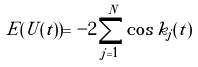Convert formula to latex. <formula><loc_0><loc_0><loc_500><loc_500>E ( U ( t ) ) = - 2 \sum _ { j = 1 } ^ { N } \cos { k _ { j } ( t ) }</formula> 